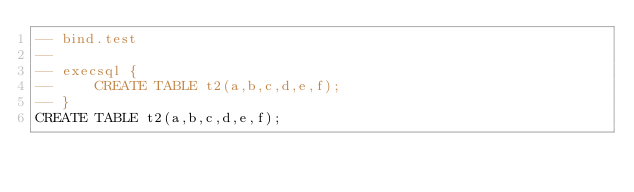<code> <loc_0><loc_0><loc_500><loc_500><_SQL_>-- bind.test
-- 
-- execsql {
--     CREATE TABLE t2(a,b,c,d,e,f);
-- }
CREATE TABLE t2(a,b,c,d,e,f);</code> 